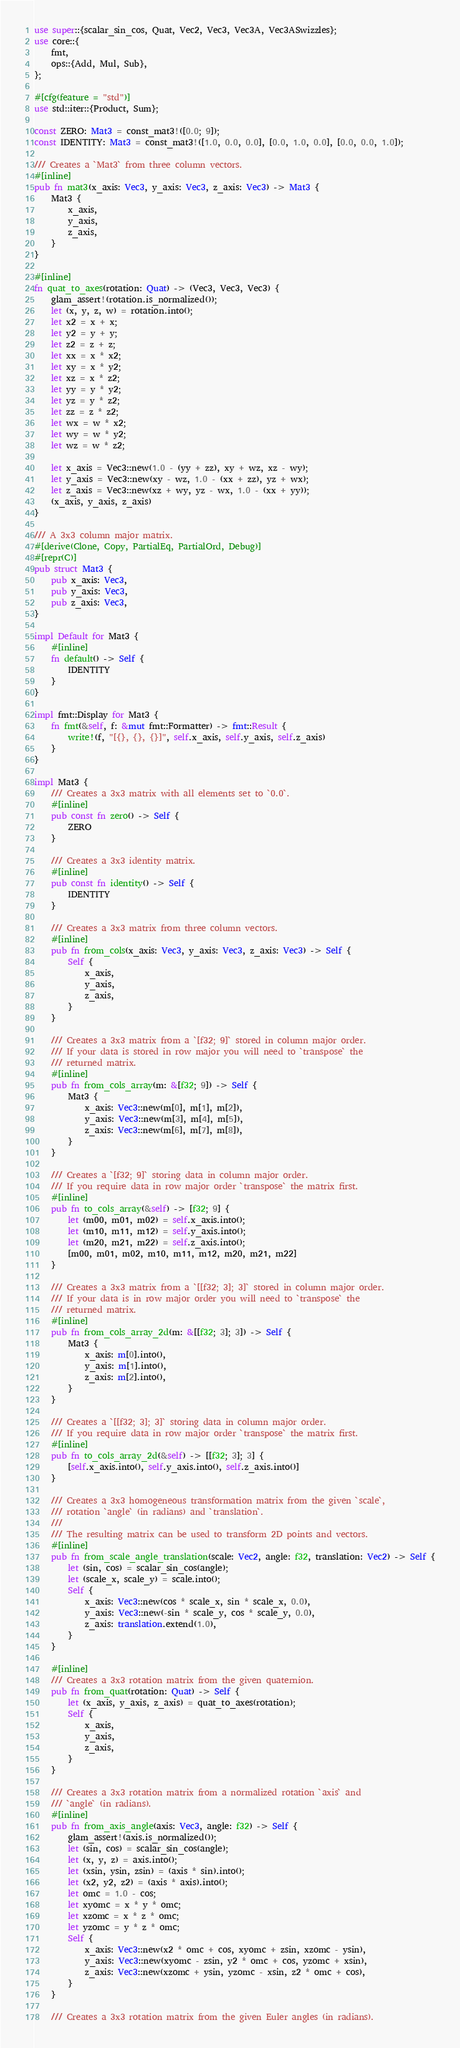<code> <loc_0><loc_0><loc_500><loc_500><_Rust_>use super::{scalar_sin_cos, Quat, Vec2, Vec3, Vec3A, Vec3ASwizzles};
use core::{
    fmt,
    ops::{Add, Mul, Sub},
};

#[cfg(feature = "std")]
use std::iter::{Product, Sum};

const ZERO: Mat3 = const_mat3!([0.0; 9]);
const IDENTITY: Mat3 = const_mat3!([1.0, 0.0, 0.0], [0.0, 1.0, 0.0], [0.0, 0.0, 1.0]);

/// Creates a `Mat3` from three column vectors.
#[inline]
pub fn mat3(x_axis: Vec3, y_axis: Vec3, z_axis: Vec3) -> Mat3 {
    Mat3 {
        x_axis,
        y_axis,
        z_axis,
    }
}

#[inline]
fn quat_to_axes(rotation: Quat) -> (Vec3, Vec3, Vec3) {
    glam_assert!(rotation.is_normalized());
    let (x, y, z, w) = rotation.into();
    let x2 = x + x;
    let y2 = y + y;
    let z2 = z + z;
    let xx = x * x2;
    let xy = x * y2;
    let xz = x * z2;
    let yy = y * y2;
    let yz = y * z2;
    let zz = z * z2;
    let wx = w * x2;
    let wy = w * y2;
    let wz = w * z2;

    let x_axis = Vec3::new(1.0 - (yy + zz), xy + wz, xz - wy);
    let y_axis = Vec3::new(xy - wz, 1.0 - (xx + zz), yz + wx);
    let z_axis = Vec3::new(xz + wy, yz - wx, 1.0 - (xx + yy));
    (x_axis, y_axis, z_axis)
}

/// A 3x3 column major matrix.
#[derive(Clone, Copy, PartialEq, PartialOrd, Debug)]
#[repr(C)]
pub struct Mat3 {
    pub x_axis: Vec3,
    pub y_axis: Vec3,
    pub z_axis: Vec3,
}

impl Default for Mat3 {
    #[inline]
    fn default() -> Self {
        IDENTITY
    }
}

impl fmt::Display for Mat3 {
    fn fmt(&self, f: &mut fmt::Formatter) -> fmt::Result {
        write!(f, "[{}, {}, {}]", self.x_axis, self.y_axis, self.z_axis)
    }
}

impl Mat3 {
    /// Creates a 3x3 matrix with all elements set to `0.0`.
    #[inline]
    pub const fn zero() -> Self {
        ZERO
    }

    /// Creates a 3x3 identity matrix.
    #[inline]
    pub const fn identity() -> Self {
        IDENTITY
    }

    /// Creates a 3x3 matrix from three column vectors.
    #[inline]
    pub fn from_cols(x_axis: Vec3, y_axis: Vec3, z_axis: Vec3) -> Self {
        Self {
            x_axis,
            y_axis,
            z_axis,
        }
    }

    /// Creates a 3x3 matrix from a `[f32; 9]` stored in column major order.
    /// If your data is stored in row major you will need to `transpose` the
    /// returned matrix.
    #[inline]
    pub fn from_cols_array(m: &[f32; 9]) -> Self {
        Mat3 {
            x_axis: Vec3::new(m[0], m[1], m[2]),
            y_axis: Vec3::new(m[3], m[4], m[5]),
            z_axis: Vec3::new(m[6], m[7], m[8]),
        }
    }

    /// Creates a `[f32; 9]` storing data in column major order.
    /// If you require data in row major order `transpose` the matrix first.
    #[inline]
    pub fn to_cols_array(&self) -> [f32; 9] {
        let (m00, m01, m02) = self.x_axis.into();
        let (m10, m11, m12) = self.y_axis.into();
        let (m20, m21, m22) = self.z_axis.into();
        [m00, m01, m02, m10, m11, m12, m20, m21, m22]
    }

    /// Creates a 3x3 matrix from a `[[f32; 3]; 3]` stored in column major order.
    /// If your data is in row major order you will need to `transpose` the
    /// returned matrix.
    #[inline]
    pub fn from_cols_array_2d(m: &[[f32; 3]; 3]) -> Self {
        Mat3 {
            x_axis: m[0].into(),
            y_axis: m[1].into(),
            z_axis: m[2].into(),
        }
    }

    /// Creates a `[[f32; 3]; 3]` storing data in column major order.
    /// If you require data in row major order `transpose` the matrix first.
    #[inline]
    pub fn to_cols_array_2d(&self) -> [[f32; 3]; 3] {
        [self.x_axis.into(), self.y_axis.into(), self.z_axis.into()]
    }

    /// Creates a 3x3 homogeneous transformation matrix from the given `scale`,
    /// rotation `angle` (in radians) and `translation`.
    ///
    /// The resulting matrix can be used to transform 2D points and vectors.
    #[inline]
    pub fn from_scale_angle_translation(scale: Vec2, angle: f32, translation: Vec2) -> Self {
        let (sin, cos) = scalar_sin_cos(angle);
        let (scale_x, scale_y) = scale.into();
        Self {
            x_axis: Vec3::new(cos * scale_x, sin * scale_x, 0.0),
            y_axis: Vec3::new(-sin * scale_y, cos * scale_y, 0.0),
            z_axis: translation.extend(1.0),
        }
    }

    #[inline]
    /// Creates a 3x3 rotation matrix from the given quaternion.
    pub fn from_quat(rotation: Quat) -> Self {
        let (x_axis, y_axis, z_axis) = quat_to_axes(rotation);
        Self {
            x_axis,
            y_axis,
            z_axis,
        }
    }

    /// Creates a 3x3 rotation matrix from a normalized rotation `axis` and
    /// `angle` (in radians).
    #[inline]
    pub fn from_axis_angle(axis: Vec3, angle: f32) -> Self {
        glam_assert!(axis.is_normalized());
        let (sin, cos) = scalar_sin_cos(angle);
        let (x, y, z) = axis.into();
        let (xsin, ysin, zsin) = (axis * sin).into();
        let (x2, y2, z2) = (axis * axis).into();
        let omc = 1.0 - cos;
        let xyomc = x * y * omc;
        let xzomc = x * z * omc;
        let yzomc = y * z * omc;
        Self {
            x_axis: Vec3::new(x2 * omc + cos, xyomc + zsin, xzomc - ysin),
            y_axis: Vec3::new(xyomc - zsin, y2 * omc + cos, yzomc + xsin),
            z_axis: Vec3::new(xzomc + ysin, yzomc - xsin, z2 * omc + cos),
        }
    }

    /// Creates a 3x3 rotation matrix from the given Euler angles (in radians).</code> 